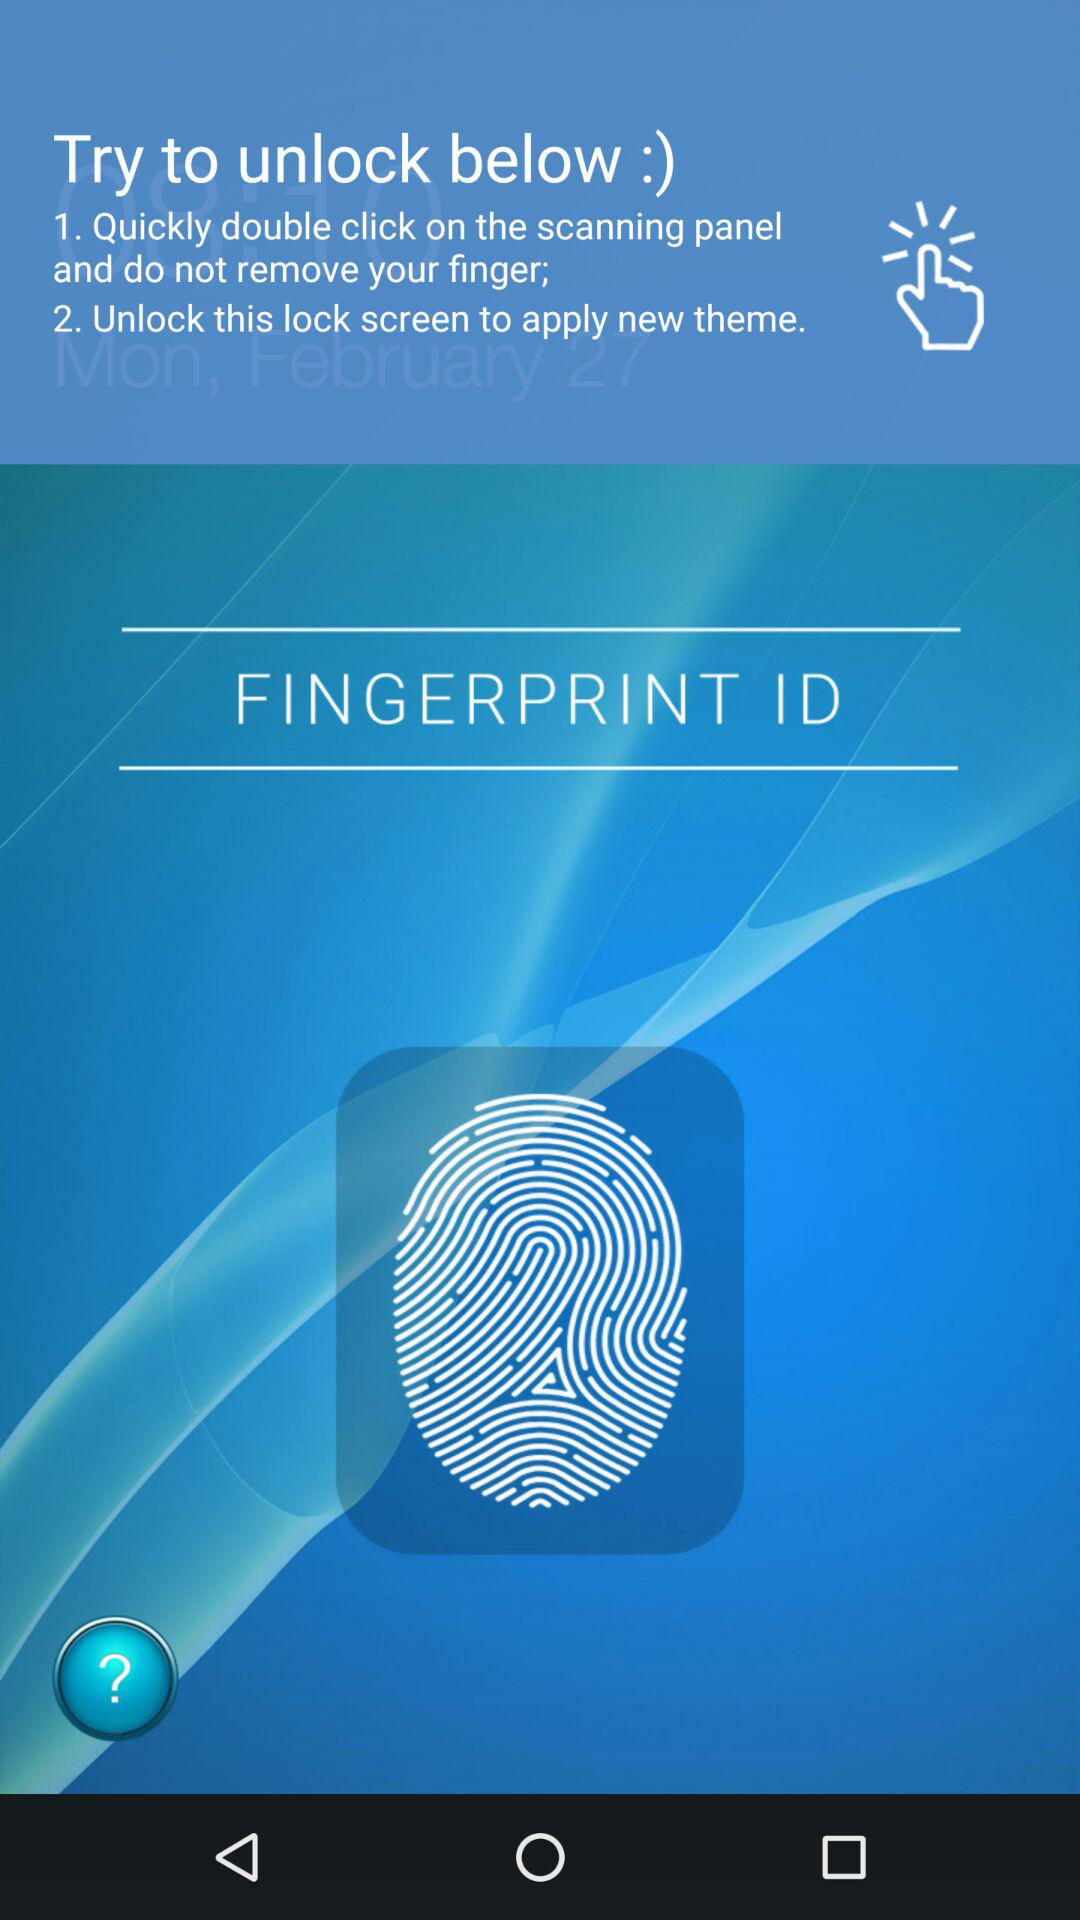How many instructions are there to unlock the screen?
Answer the question using a single word or phrase. 2 